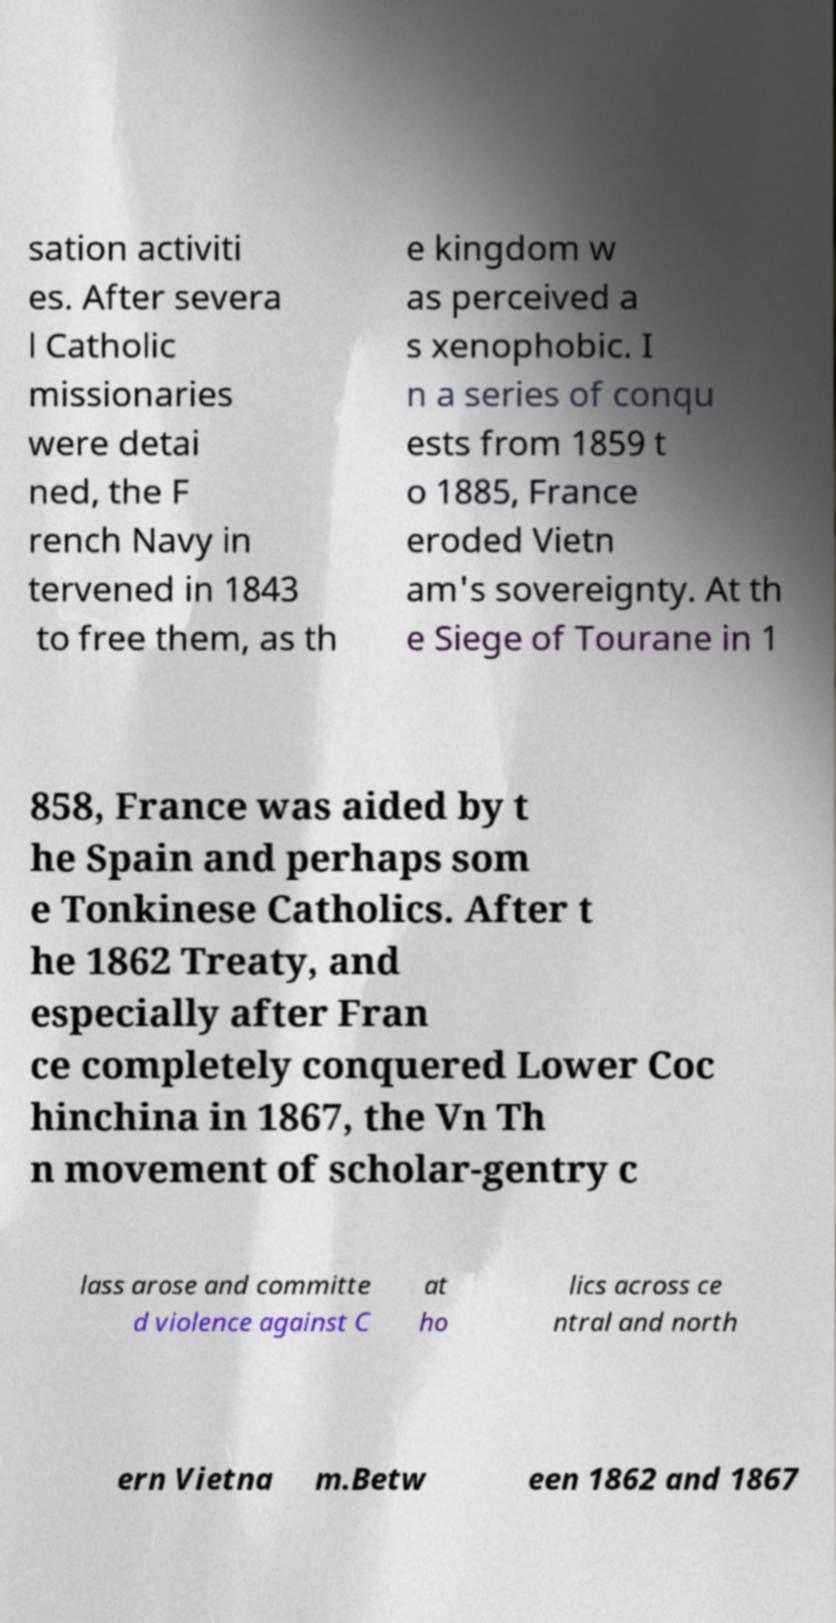Can you accurately transcribe the text from the provided image for me? sation activiti es. After severa l Catholic missionaries were detai ned, the F rench Navy in tervened in 1843 to free them, as th e kingdom w as perceived a s xenophobic. I n a series of conqu ests from 1859 t o 1885, France eroded Vietn am's sovereignty. At th e Siege of Tourane in 1 858, France was aided by t he Spain and perhaps som e Tonkinese Catholics. After t he 1862 Treaty, and especially after Fran ce completely conquered Lower Coc hinchina in 1867, the Vn Th n movement of scholar-gentry c lass arose and committe d violence against C at ho lics across ce ntral and north ern Vietna m.Betw een 1862 and 1867 